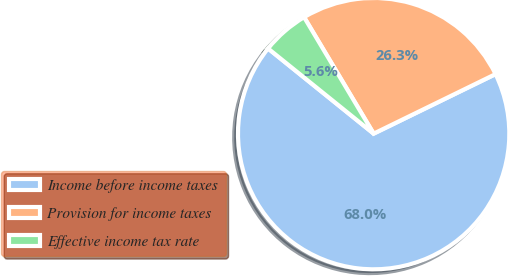Convert chart. <chart><loc_0><loc_0><loc_500><loc_500><pie_chart><fcel>Income before income taxes<fcel>Provision for income taxes<fcel>Effective income tax rate<nl><fcel>68.03%<fcel>26.34%<fcel>5.63%<nl></chart> 